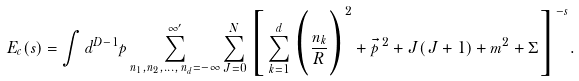Convert formula to latex. <formula><loc_0><loc_0><loc_500><loc_500>E _ { c } ( s ) = \int d ^ { D - 1 } p \sum ^ { \infty ^ { \prime } } _ { n _ { 1 } , n _ { 2 } , \dots , { \, } n _ { d } = - \infty } \sum _ { J = 0 } ^ { N } \Big { [ } \sum _ { k = 1 } ^ { d } \Big { ( } \frac { n _ { k } } { R } \Big { ) } ^ { 2 } + \vec { p } { \, } ^ { 2 } + J ( J + 1 ) + m ^ { 2 } + \Sigma \Big { ] } ^ { - s } .</formula> 